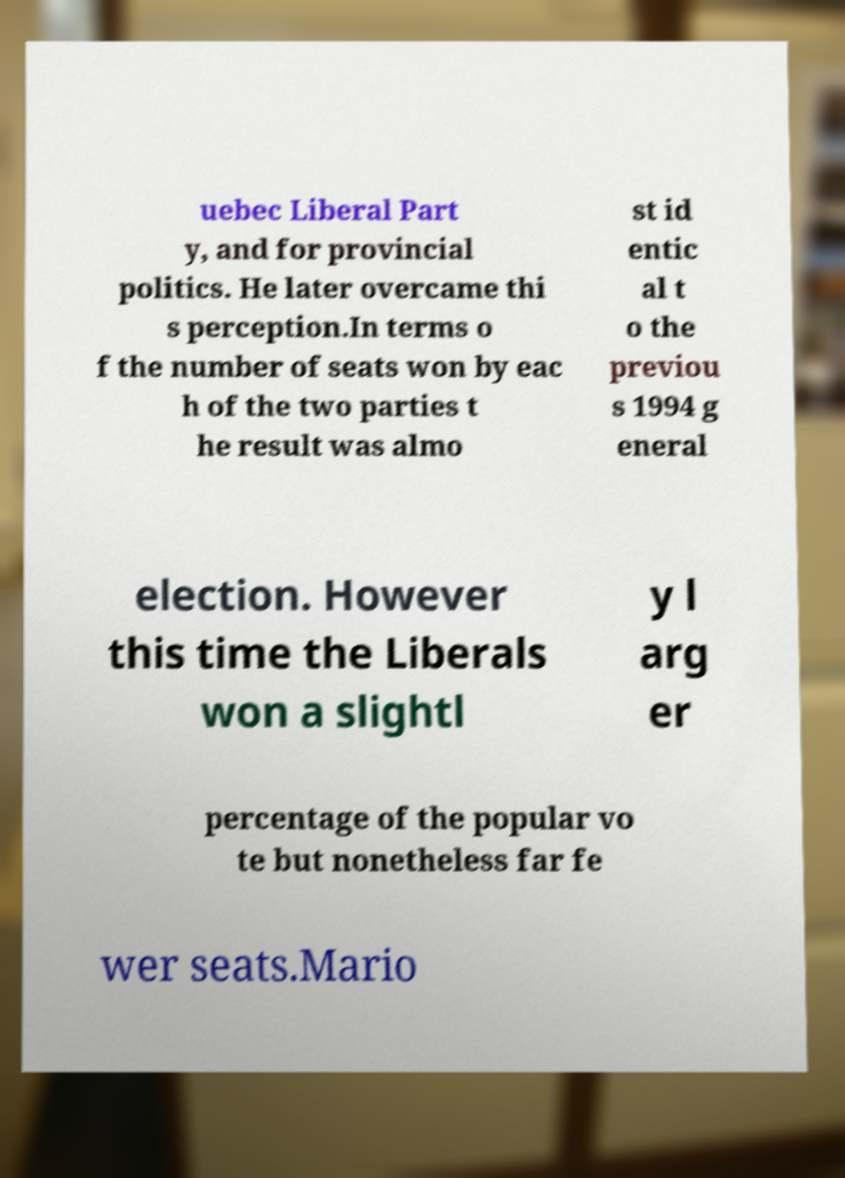There's text embedded in this image that I need extracted. Can you transcribe it verbatim? uebec Liberal Part y, and for provincial politics. He later overcame thi s perception.In terms o f the number of seats won by eac h of the two parties t he result was almo st id entic al t o the previou s 1994 g eneral election. However this time the Liberals won a slightl y l arg er percentage of the popular vo te but nonetheless far fe wer seats.Mario 